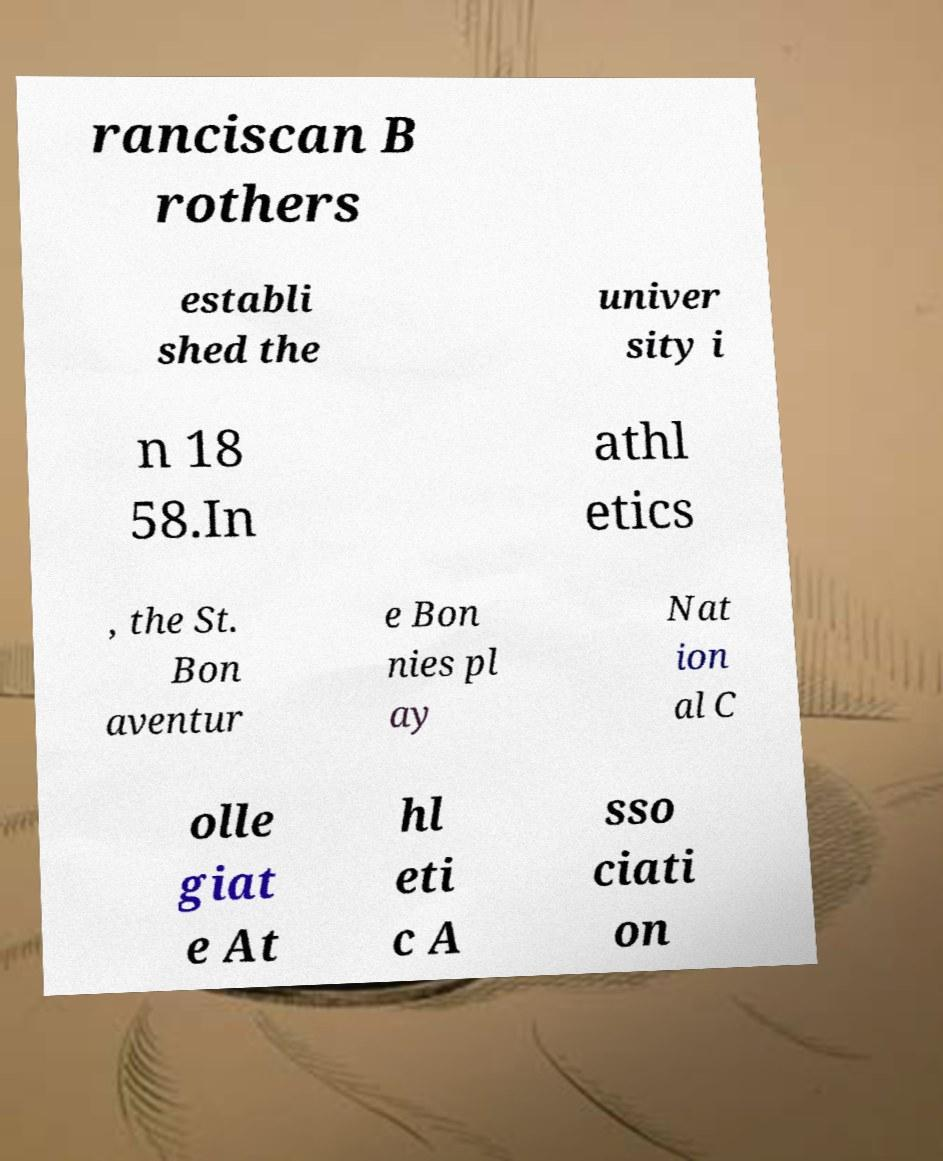Can you accurately transcribe the text from the provided image for me? ranciscan B rothers establi shed the univer sity i n 18 58.In athl etics , the St. Bon aventur e Bon nies pl ay Nat ion al C olle giat e At hl eti c A sso ciati on 